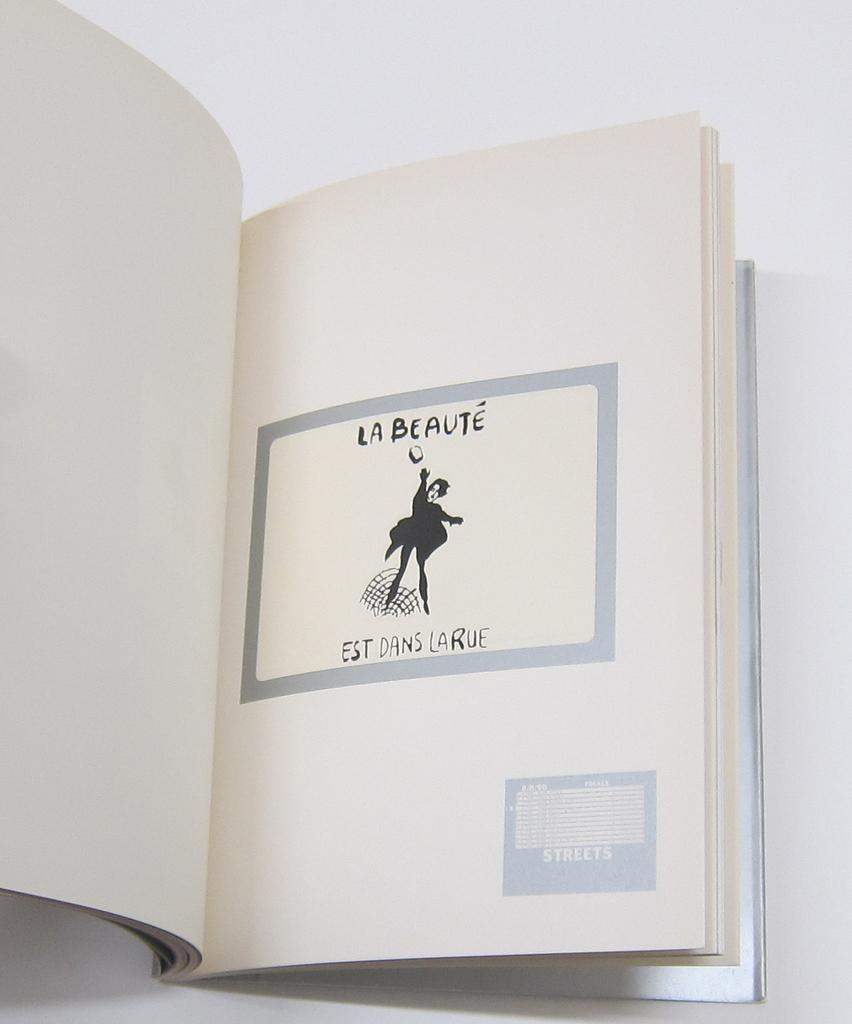<image>
Create a compact narrative representing the image presented. a book that is white in color called La Beaute 